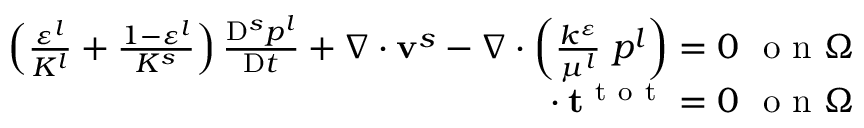Convert formula to latex. <formula><loc_0><loc_0><loc_500><loc_500>\begin{array} { r } { \left ( \frac { \varepsilon ^ { l } } { K ^ { l } } + \frac { 1 - \varepsilon ^ { l } } { K ^ { s } } \right ) \frac { D ^ { s } p ^ { l } } { D t } + \nabla \cdot v ^ { s } - \nabla \cdot \left ( \frac { k ^ { \varepsilon } } { \mu ^ { l } } \nabla p ^ { l } \right ) = 0 o n \Omega } \\ { \nabla \cdot t ^ { t o t } = 0 o n \Omega } \end{array}</formula> 